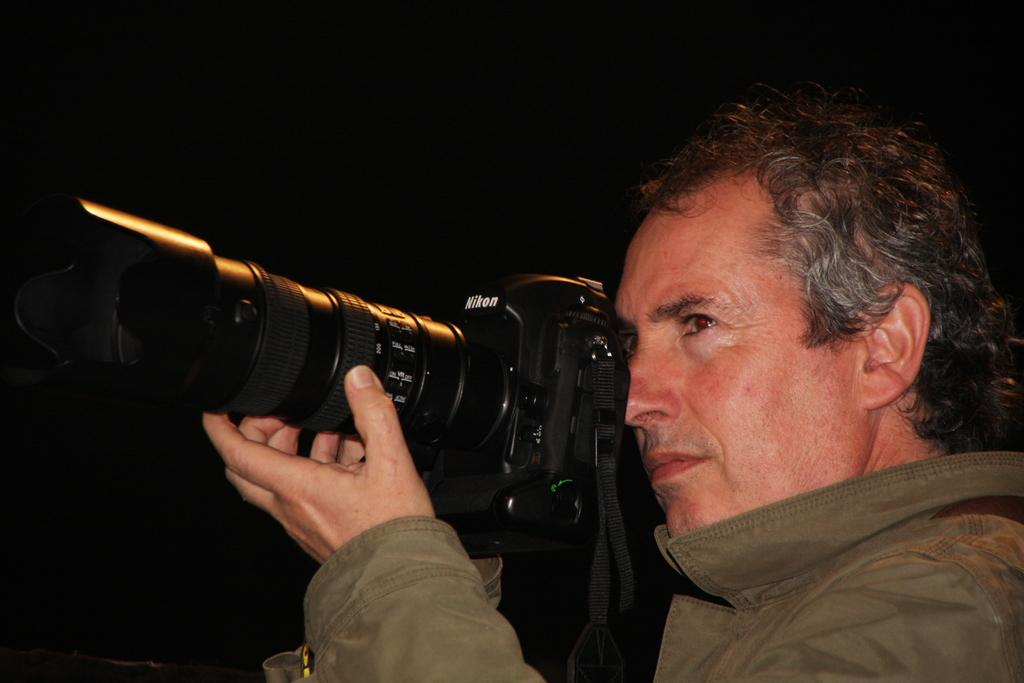What is the main subject of the image? There is a man in the image. What is the man holding in the image? The man is holding a camera. What type of scarf is the man wearing in the image? There is no scarf present in the image. Can you tell me how many goldfish are swimming in the image? There are no goldfish present in the image. 